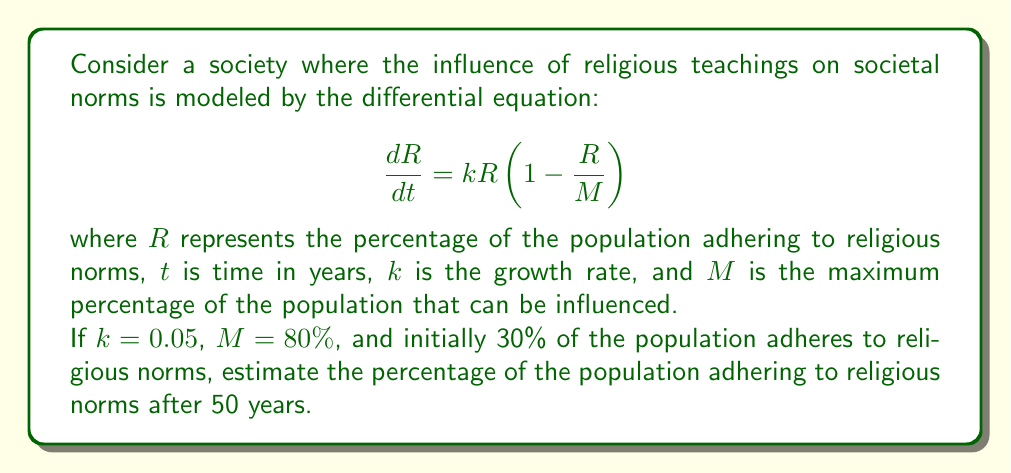Could you help me with this problem? To solve this problem, we need to use the logistic growth model, which is a first-order differential equation.

1) The given equation is in the form of the logistic growth model:

   $$\frac{dR}{dt} = kR(1-\frac{R}{M})$$

2) We are given:
   - $k = 0.05$ (growth rate)
   - $M = 80\%$ (maximum percentage)
   - $R_0 = 30\%$ (initial percentage at $t=0$)
   - We need to find $R$ when $t = 50$ years

3) The solution to the logistic growth model is:

   $$R(t) = \frac{MR_0}{R_0 + (M-R_0)e^{-kt}}$$

4) Substituting the given values:

   $$R(t) = \frac{80 \cdot 30}{30 + (80-30)e^{-0.05t}}$$

5) Simplify:

   $$R(t) = \frac{2400}{30 + 50e^{-0.05t}}$$

6) Now, we need to calculate $R(50)$:

   $$R(50) = \frac{2400}{30 + 50e^{-0.05(50)}}$$

7) Calculate $e^{-0.05(50)} \approx 0.0821$

8) Substitute this value:

   $$R(50) = \frac{2400}{30 + 50(0.0821)} \approx 71.43$$

Therefore, after 50 years, approximately 71.43% of the population will adhere to religious norms.
Answer: 71.43% 